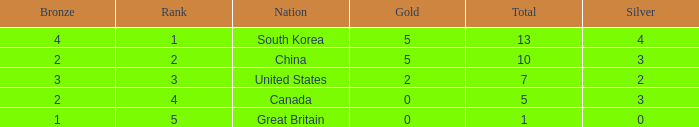What is the lowest Gold, when Nation is Canada, and when Rank is greater than 4? None. 